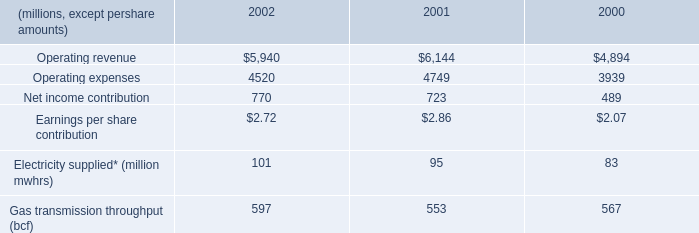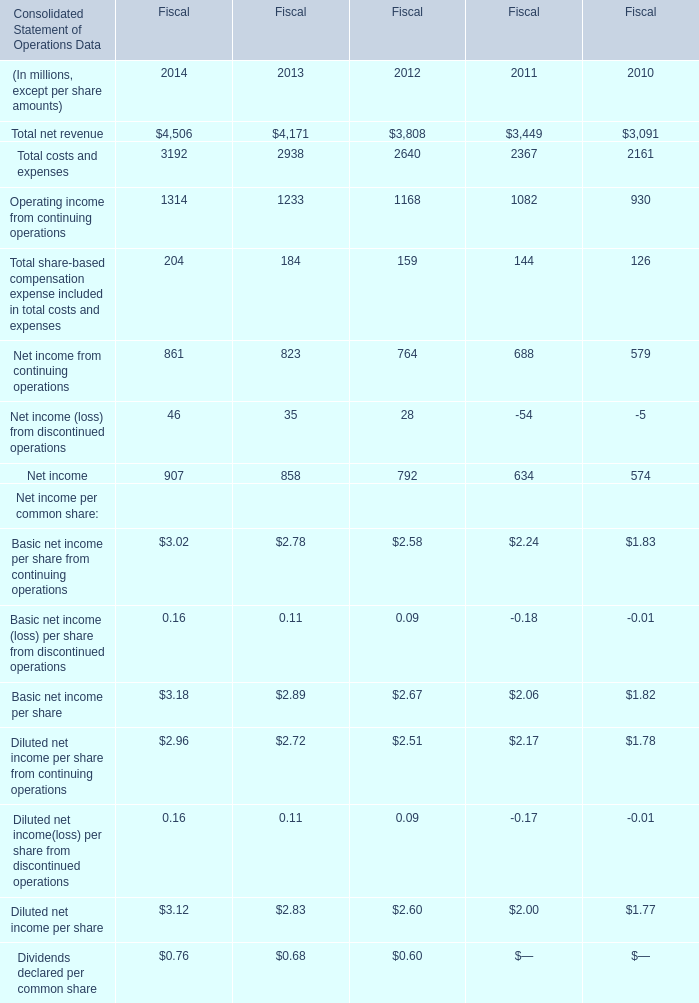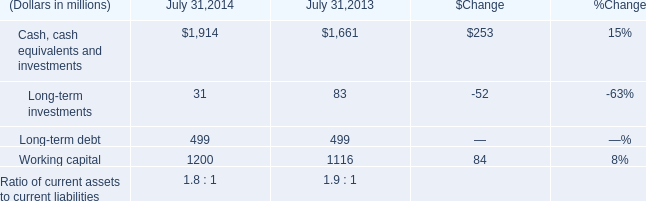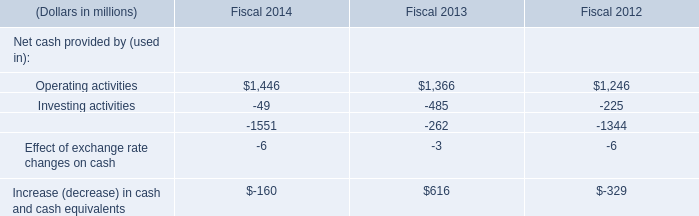If Net income develops with the same increasing rate in 2014 for Fiscal, what will it reach in 2015 for Fiscal? (in million) 
Computations: (907 * (1 + ((907 - 858) / 858)))
Answer: 958.79837. 